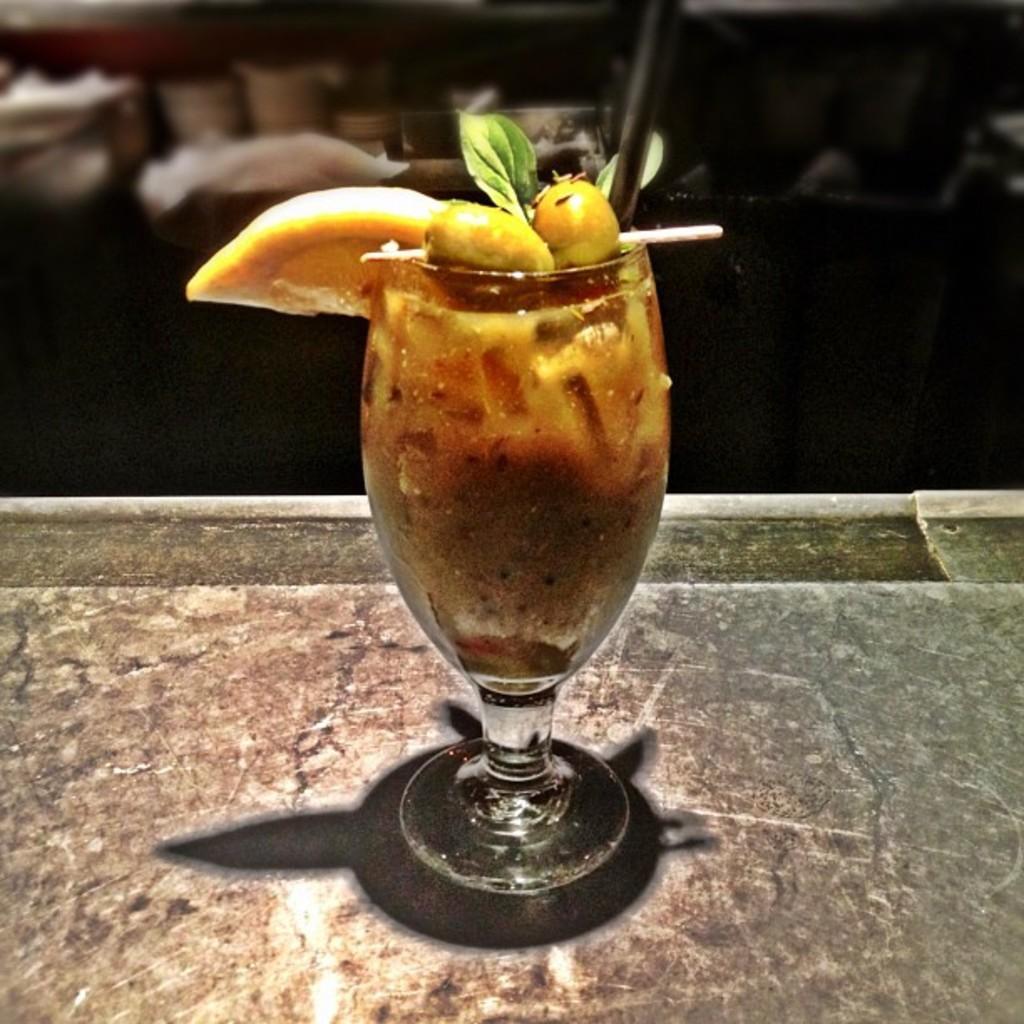How would you summarize this image in a sentence or two? In this picture I can see the juice glass which is kept on the tray. In the back I can see the tables and chairs. 